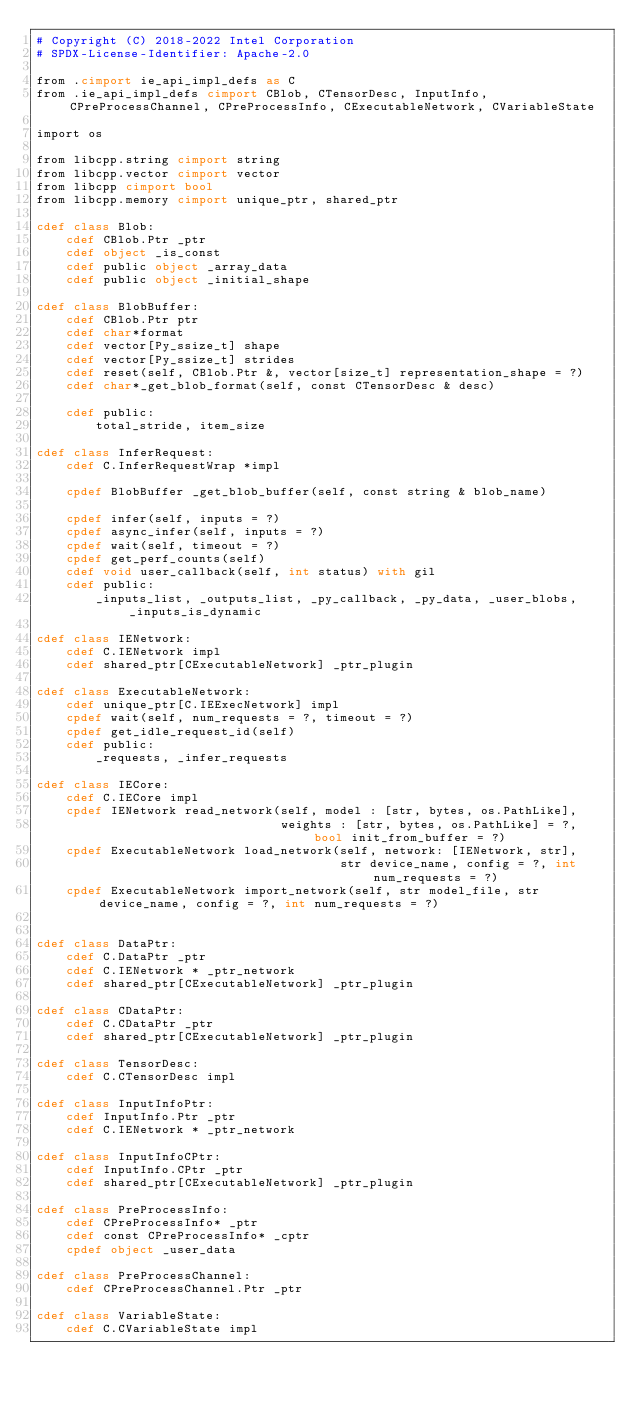<code> <loc_0><loc_0><loc_500><loc_500><_Cython_># Copyright (C) 2018-2022 Intel Corporation
# SPDX-License-Identifier: Apache-2.0

from .cimport ie_api_impl_defs as C
from .ie_api_impl_defs cimport CBlob, CTensorDesc, InputInfo, CPreProcessChannel, CPreProcessInfo, CExecutableNetwork, CVariableState

import os

from libcpp.string cimport string
from libcpp.vector cimport vector
from libcpp cimport bool
from libcpp.memory cimport unique_ptr, shared_ptr

cdef class Blob:
    cdef CBlob.Ptr _ptr
    cdef object _is_const
    cdef public object _array_data
    cdef public object _initial_shape

cdef class BlobBuffer:
    cdef CBlob.Ptr ptr
    cdef char*format
    cdef vector[Py_ssize_t] shape
    cdef vector[Py_ssize_t] strides
    cdef reset(self, CBlob.Ptr &, vector[size_t] representation_shape = ?)
    cdef char*_get_blob_format(self, const CTensorDesc & desc)

    cdef public:
        total_stride, item_size

cdef class InferRequest:
    cdef C.InferRequestWrap *impl

    cpdef BlobBuffer _get_blob_buffer(self, const string & blob_name)

    cpdef infer(self, inputs = ?)
    cpdef async_infer(self, inputs = ?)
    cpdef wait(self, timeout = ?)
    cpdef get_perf_counts(self)
    cdef void user_callback(self, int status) with gil
    cdef public:
        _inputs_list, _outputs_list, _py_callback, _py_data, _user_blobs, _inputs_is_dynamic

cdef class IENetwork:
    cdef C.IENetwork impl
    cdef shared_ptr[CExecutableNetwork] _ptr_plugin

cdef class ExecutableNetwork:
    cdef unique_ptr[C.IEExecNetwork] impl
    cpdef wait(self, num_requests = ?, timeout = ?)
    cpdef get_idle_request_id(self)
    cdef public:
        _requests, _infer_requests

cdef class IECore:
    cdef C.IECore impl
    cpdef IENetwork read_network(self, model : [str, bytes, os.PathLike],
                                 weights : [str, bytes, os.PathLike] = ?, bool init_from_buffer = ?)
    cpdef ExecutableNetwork load_network(self, network: [IENetwork, str],
                                         str device_name, config = ?, int num_requests = ?)
    cpdef ExecutableNetwork import_network(self, str model_file, str device_name, config = ?, int num_requests = ?)


cdef class DataPtr:
    cdef C.DataPtr _ptr
    cdef C.IENetwork * _ptr_network
    cdef shared_ptr[CExecutableNetwork] _ptr_plugin

cdef class CDataPtr:
    cdef C.CDataPtr _ptr
    cdef shared_ptr[CExecutableNetwork] _ptr_plugin

cdef class TensorDesc:
    cdef C.CTensorDesc impl

cdef class InputInfoPtr:
    cdef InputInfo.Ptr _ptr
    cdef C.IENetwork * _ptr_network

cdef class InputInfoCPtr:
    cdef InputInfo.CPtr _ptr
    cdef shared_ptr[CExecutableNetwork] _ptr_plugin

cdef class PreProcessInfo:
    cdef CPreProcessInfo* _ptr
    cdef const CPreProcessInfo* _cptr
    cpdef object _user_data

cdef class PreProcessChannel:
    cdef CPreProcessChannel.Ptr _ptr

cdef class VariableState:
    cdef C.CVariableState impl
</code> 